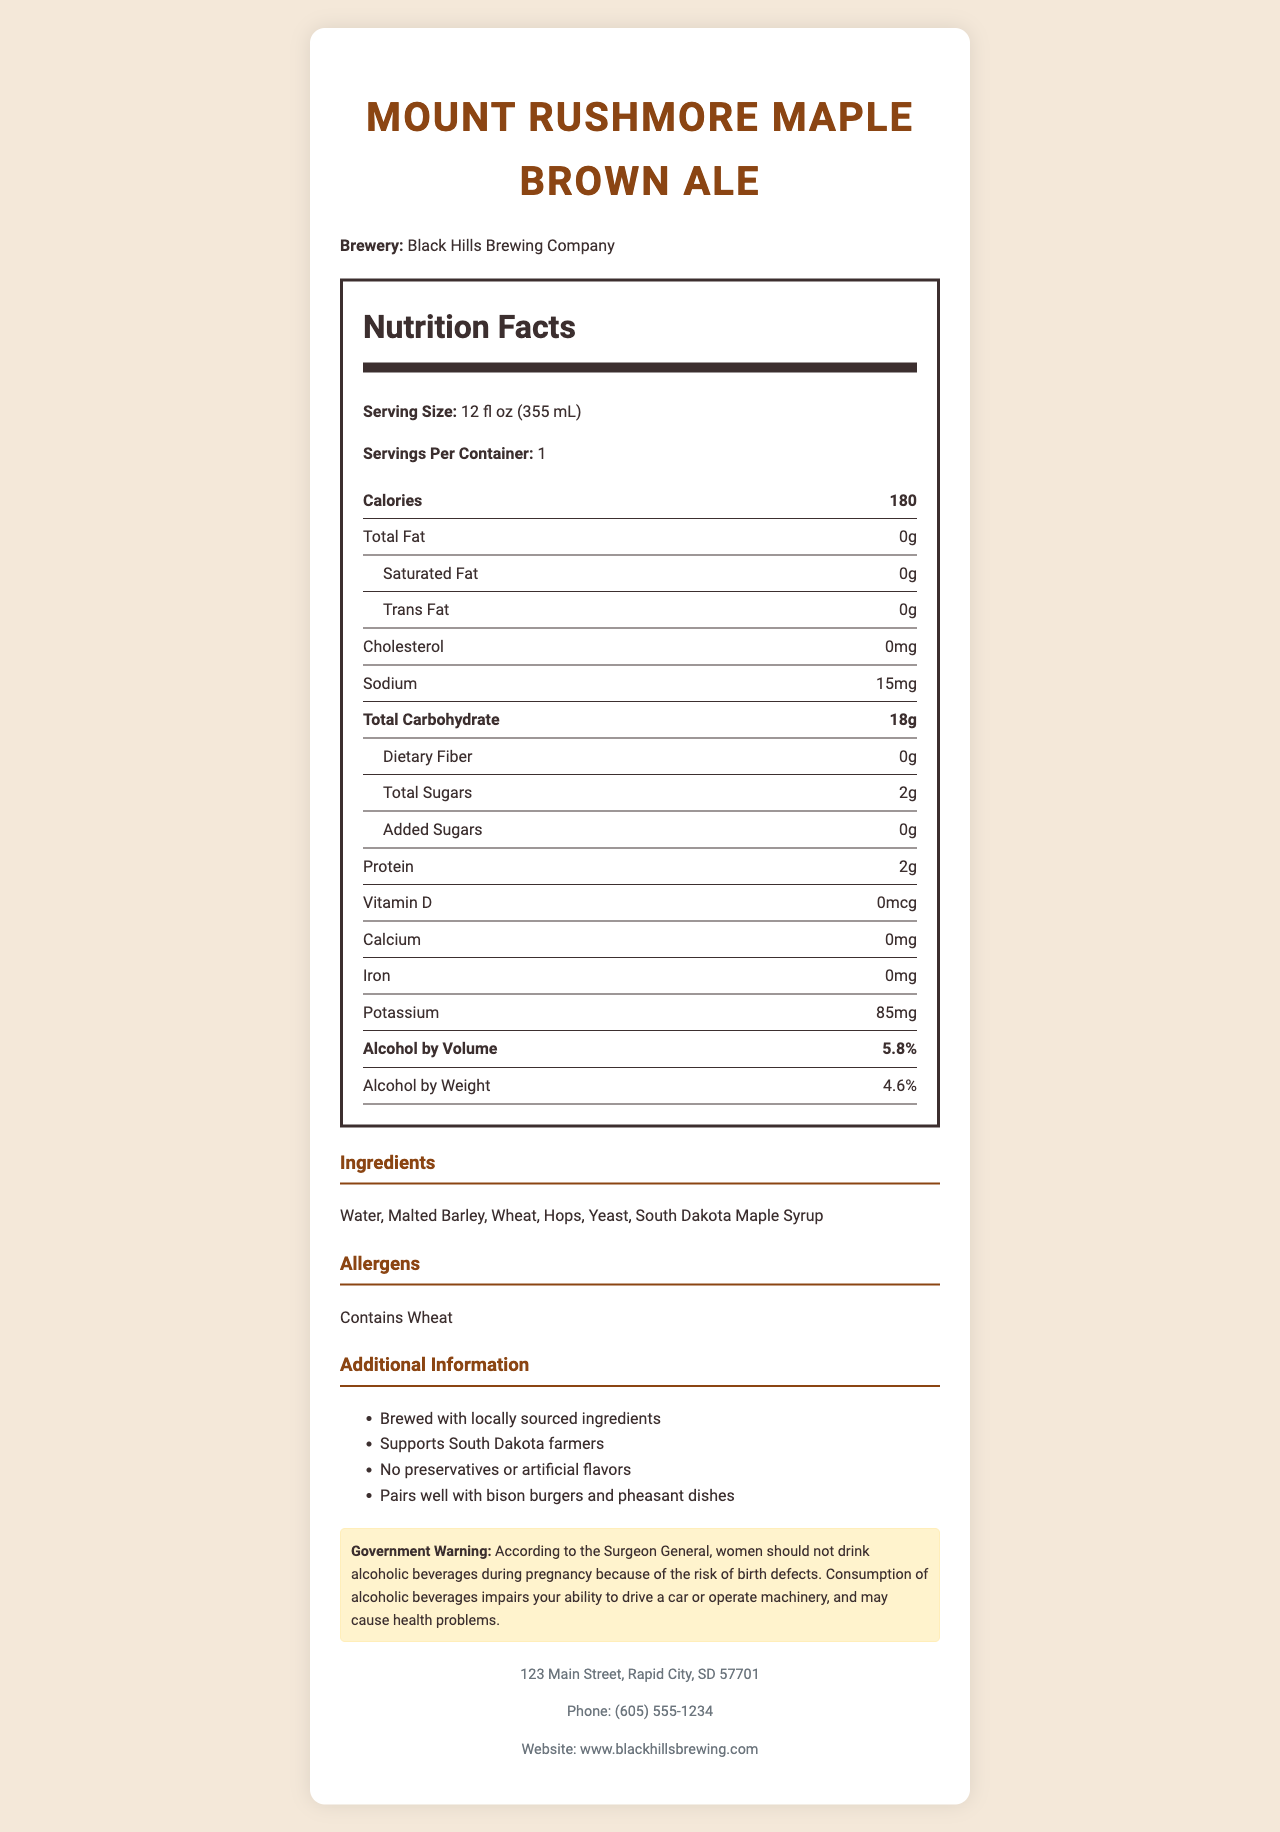How many calories are in one serving of Mount Rushmore Maple Brown Ale? The document lists 180 calories per 12 fl oz serving.
Answer: 180 What is the alcohol by volume (ABV) percentage? The document specifies that the alcohol by volume is 5.8%.
Answer: 5.8% What container type is used for this craft beer? The document indicates that the packaging is a recyclable glass bottle.
Answer: Recyclable glass bottle How much sodium is in one serving? The document lists that there are 15 mg of sodium per serving.
Answer: 15 mg List three benefits or additional information about Mount Rushmore Maple Brown Ale. These points are highlighted in the additional info section of the document.
Answer: Brewed with locally sourced ingredients, Supports South Dakota farmers, No preservatives or artificial flavors What is the serving size? A. 10 fl oz (295 mL) B. 12 fl oz (355 mL) C. 16 fl oz (473 mL) The serving size mentioned in the document is 12 fl oz (355 mL).
Answer: B. 12 fl oz (355 mL) Which ingredient listed indicates a potential allergen? A. Water B. Malted Barley C. Wheat The allergens section specifically states that the product contains wheat.
Answer: C. Wheat Is Mount Rushmore Maple Brown Ale certified by the Craft Brewers Association? The document includes a certification from the Craft Brewers Association.
Answer: Yes Does the beer contain any added sugars? The document states that there are 0 grams of added sugars.
Answer: No Summarize the key nutritional contents of Mount Rushmore Maple Brown Ale. The document provides comprehensive nutritional information and emphasizes the local sourcing and health-conscious nature of the product.
Answer: This craft beer has 180 calories per serving, 0 grams of total fat, 18 grams of total carbohydrates, and 2 grams of protein. It includes 5.8% alcohol by volume and 4.6% alcohol by weight. Key additional information includes being brewed with locally sourced ingredients, supporting South Dakota farmers, and containing no preservatives or artificial flavors. How many grams of dietary fiber are there in one serving? The document lists dietary fiber as 0 grams per serving.
Answer: 0 grams How many servings are in one container of Mount Rushmore Maple Brown Ale? The document states that there is 1 serving per container.
Answer: 1 Is there any information about the vitamin D content in the beer? The document lists vitamin D content as 0 mcg.
Answer: Yes What is the address of Black Hills Brewing Company? The contact section of the document provides this address.
Answer: 123 Main Street, Rapid City, SD 57701 Which one of the following dishes pairs well with Mount Rushmore Maple Brown Ale? A. Grilled Chicken B. Bison Burgers C. Vegetarian Pasta The additional info section states that the beer pairs well with bison burgers and pheasant dishes.
Answer: B. Bison Burgers How much protein does the beer contain? The document specifies that there are 2 grams of protein per serving.
Answer: 2 grams What is the brewery phone number provided in the document? The contact section lists the phone number as (605) 555-1234.
Answer: (605) 555-1234 Does the beer support South Dakota farmers? The additional information section mentions that the beer supports South Dakota farmers.
Answer: Yes What is the iron content listed in the document? The document states that the iron content is 0 mg per serving.
Answer: 0 mg How much potassium is there in one serving? The document lists 85 mg of potassium per serving.
Answer: 85 mg Who should avoid drinking Mount Rushmore Maple Brown Ale according to the government warning? The government warning states that women should not drink alcoholic beverages during pregnancy due to the risk of birth defects.
Answer: Women who may become pregnant Does the document specify the production date? The document does not provide any details regarding the production date.
Answer: Not enough information Where can more information be found about the brewery online? The contact section of the document provides the website as www.blackhillsbrewing.com.
Answer: www.blackhillsbrewing.com 